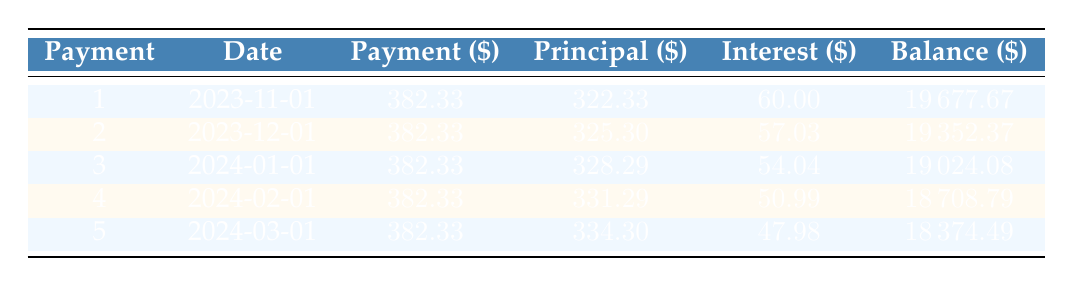What is the total payment for the first month? The payment amount for the first month is directly listed in the table under the "Payment" column for payment number 1, which is $382.33.
Answer: 382.33 How much principal was paid off in the second month? The amount of principal paid in the second month is listed in the table under the "Principal" column for payment number 2, which is $325.30.
Answer: 325.30 What is the total amount of interest paid over the first five payments? To find the total interest, we sum the "Interest" column values for each of the first five payments: $60.00 + $57.03 + $54.04 + $50.99 + $47.98 = $270.04.
Answer: 270.04 Is the interest amount paid in the fourth month greater than that paid in the second month? By comparing the "Interest" values in the table, the interest for the fourth month is $50.99 and for the second month is $57.03. Since $50.99 is less than $57.03, the answer is false.
Answer: No What is the remaining balance after the third payment? The balance after the third payment is listed under the "Balance" column for payment number 3, which is $19024.08.
Answer: 19024.08 What is the average payment towards principal over the first five payments? To calculate the average principal payment, we sum the principal amounts: $322.33 + $325.30 + $328.29 + $331.29 + $334.30 = $1631.51. Then we divide by 5 payments to find the average: $1631.51 / 5 = $326.30.
Answer: 326.30 How much less interest is paid in the fifth month compared to the first month? By comparing the interest amounts, the first month has $60.00 and the fifth month has $47.98. The difference is calculated as $60.00 - $47.98 = $12.02.
Answer: 12.02 Is the total payment amount consistent across all months in this schedule? Looking at the "Payment" column, all entries show a consistent amount of $382.33 for each of the five payments, making the total consistent. Therefore, the answer is yes.
Answer: Yes How much is the remaining loan balance after the second payment? The remaining balance after the second payment is shown in the table under the "Balance" column for payment number 2, which is $19352.37.
Answer: 19352.37 